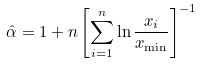<formula> <loc_0><loc_0><loc_500><loc_500>\hat { \alpha } = 1 + n \left [ \sum _ { i = 1 } ^ { n } { \ln \frac { x _ { i } } { x _ { \min } } } \right ] ^ { - 1 }</formula> 